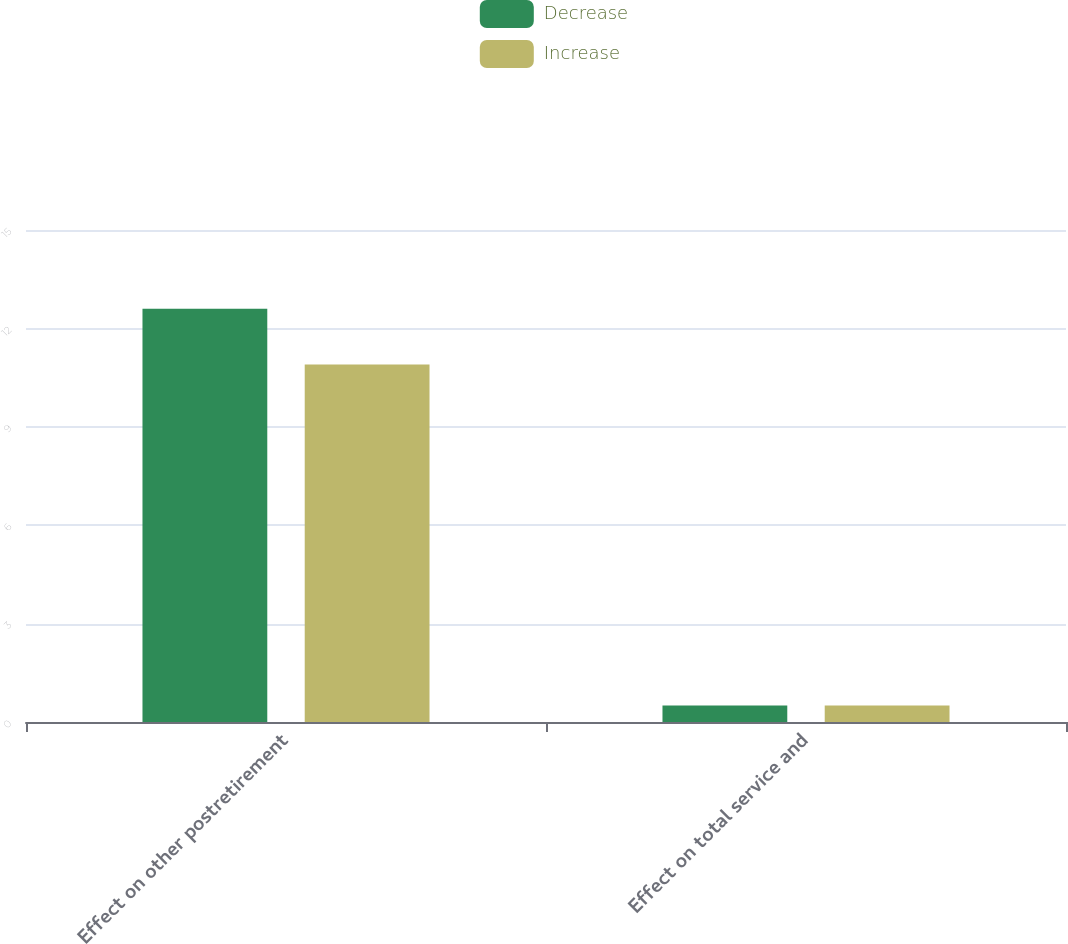Convert chart. <chart><loc_0><loc_0><loc_500><loc_500><stacked_bar_chart><ecel><fcel>Effect on other postretirement<fcel>Effect on total service and<nl><fcel>Decrease<fcel>12.6<fcel>0.5<nl><fcel>Increase<fcel>10.9<fcel>0.5<nl></chart> 